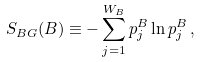<formula> <loc_0><loc_0><loc_500><loc_500>S _ { B G } ( B ) \equiv - \sum _ { j = 1 } ^ { W _ { B } } p _ { j } ^ { B } \ln p _ { j } ^ { B } \, ,</formula> 